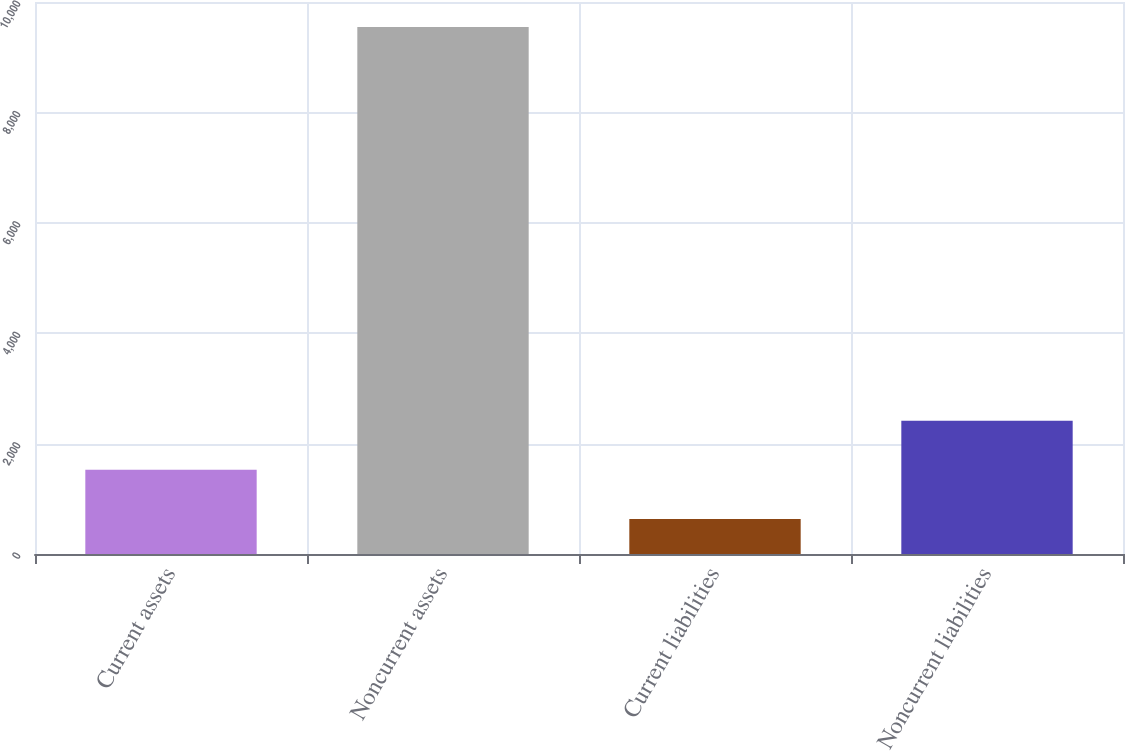Convert chart. <chart><loc_0><loc_0><loc_500><loc_500><bar_chart><fcel>Current assets<fcel>Noncurrent assets<fcel>Current liabilities<fcel>Noncurrent liabilities<nl><fcel>1524.6<fcel>9549<fcel>633<fcel>2416.2<nl></chart> 